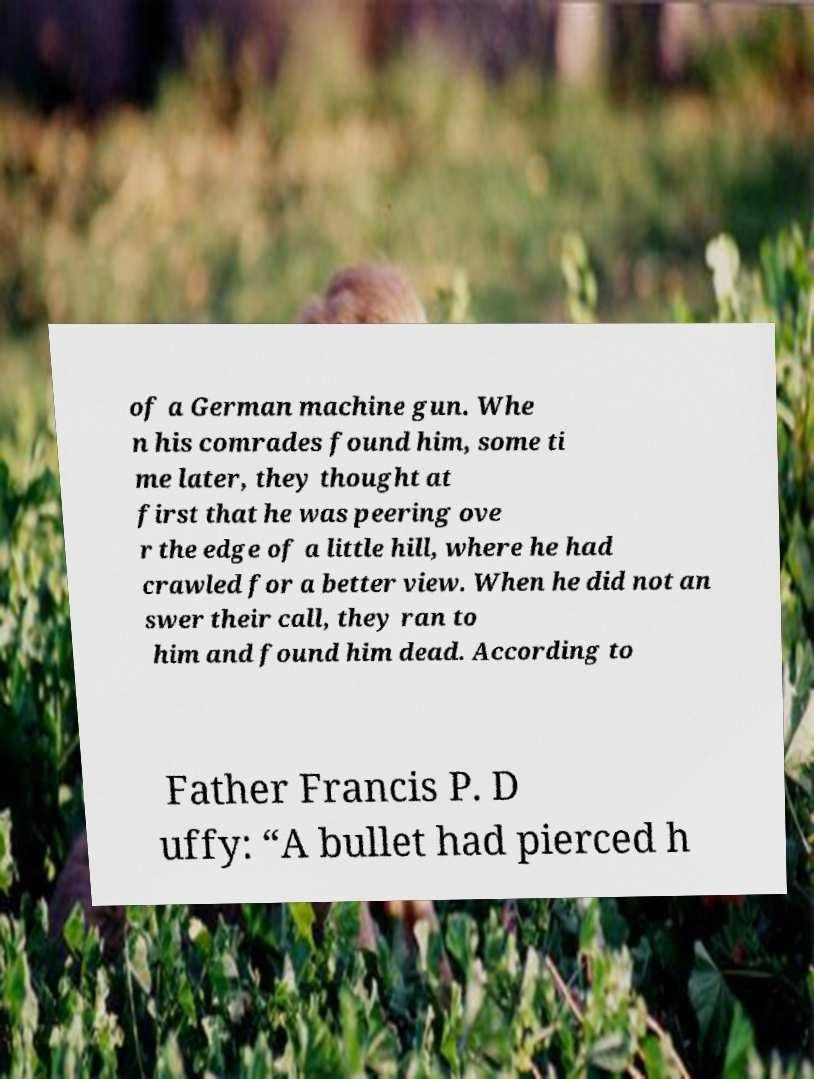What messages or text are displayed in this image? I need them in a readable, typed format. of a German machine gun. Whe n his comrades found him, some ti me later, they thought at first that he was peering ove r the edge of a little hill, where he had crawled for a better view. When he did not an swer their call, they ran to him and found him dead. According to Father Francis P. D uffy: “A bullet had pierced h 